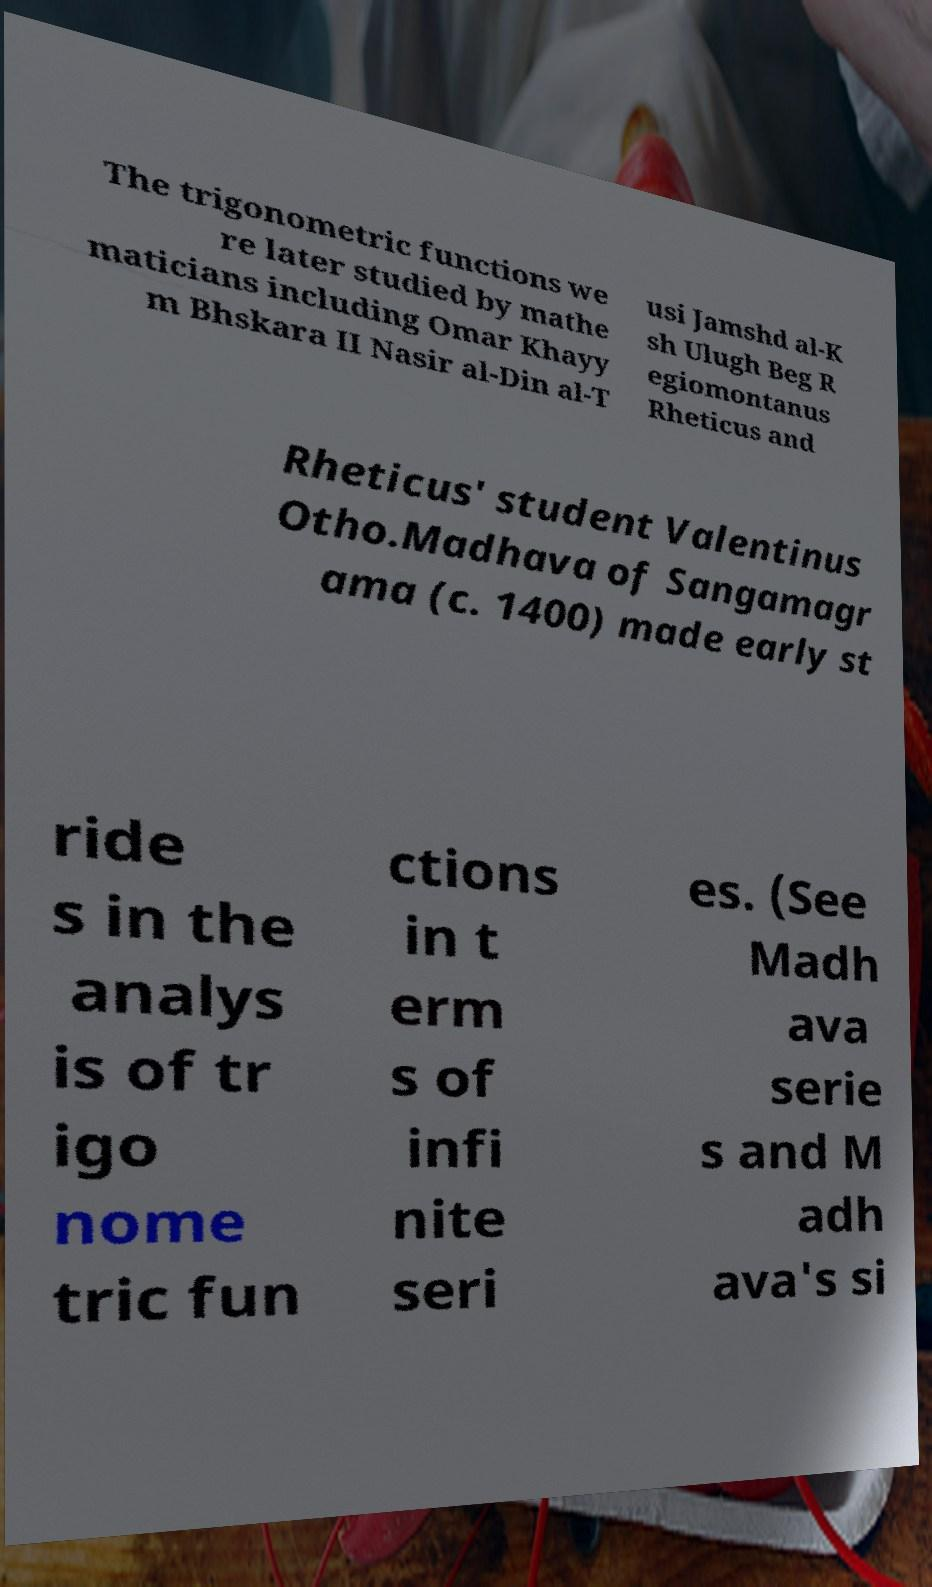For documentation purposes, I need the text within this image transcribed. Could you provide that? The trigonometric functions we re later studied by mathe maticians including Omar Khayy m Bhskara II Nasir al-Din al-T usi Jamshd al-K sh Ulugh Beg R egiomontanus Rheticus and Rheticus' student Valentinus Otho.Madhava of Sangamagr ama (c. 1400) made early st ride s in the analys is of tr igo nome tric fun ctions in t erm s of infi nite seri es. (See Madh ava serie s and M adh ava's si 